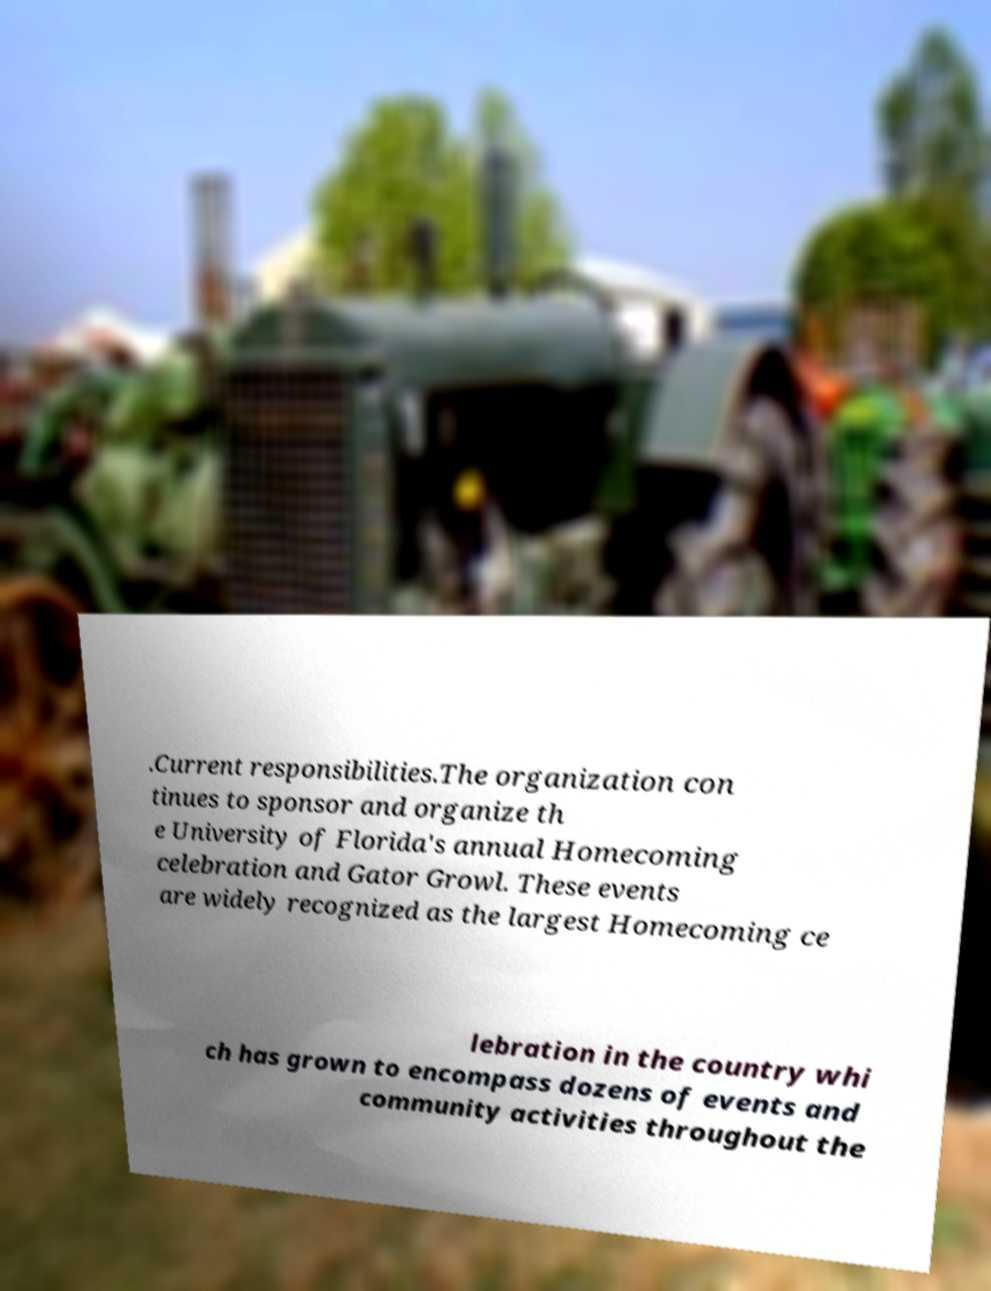Could you extract and type out the text from this image? .Current responsibilities.The organization con tinues to sponsor and organize th e University of Florida's annual Homecoming celebration and Gator Growl. These events are widely recognized as the largest Homecoming ce lebration in the country whi ch has grown to encompass dozens of events and community activities throughout the 